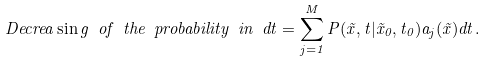Convert formula to latex. <formula><loc_0><loc_0><loc_500><loc_500>D e c r e a \sin g \ o f \ t h e \ p r o b a b i l i t y \ i n \ d t = \sum _ { j = 1 } ^ { M } P ( \vec { x } , t | \vec { x } _ { 0 } , t _ { 0 } ) a _ { j } ( \vec { x } ) d t .</formula> 